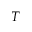Convert formula to latex. <formula><loc_0><loc_0><loc_500><loc_500>T</formula> 